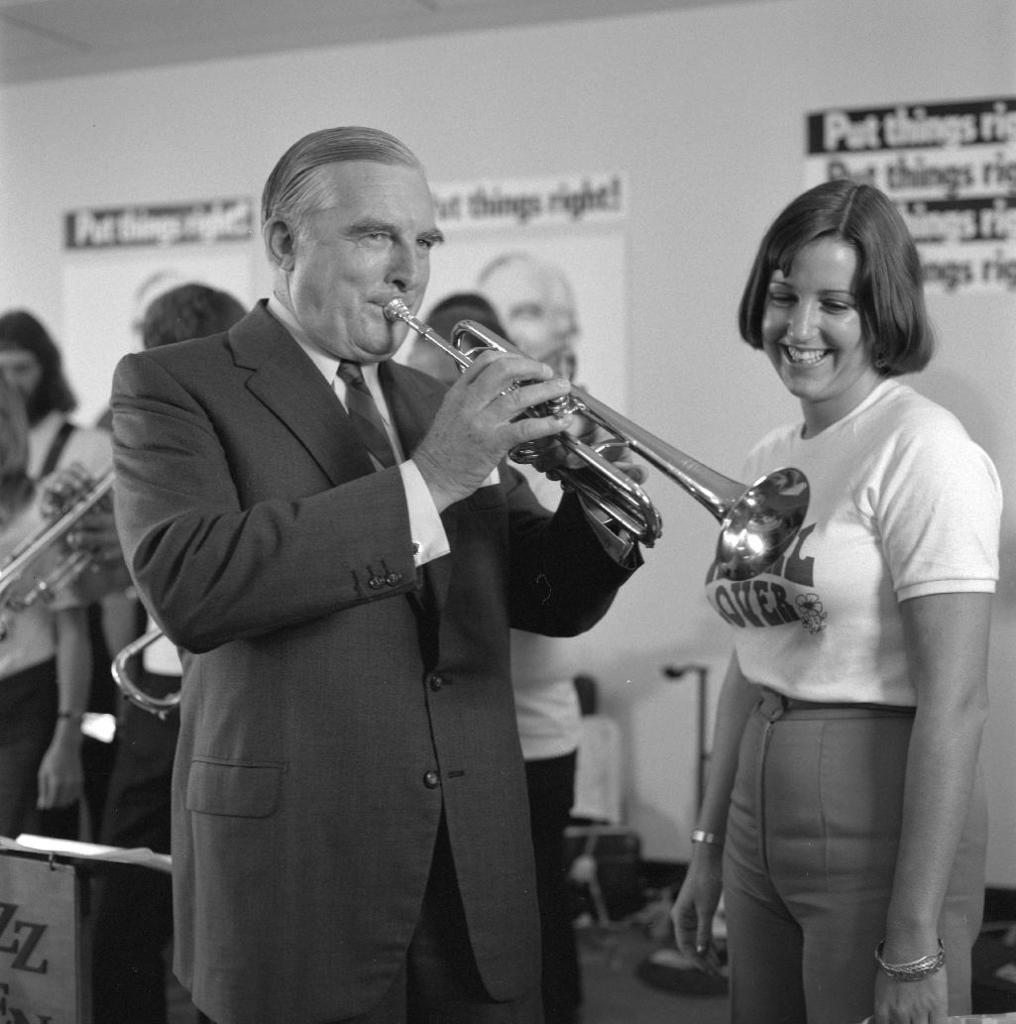In one or two sentences, can you explain what this image depicts? This image is a black and white image image. This image is taken indoors. In the background there is a wall with a few posts on it. There are a few images and there is a text on the posters. At the top of the image there is a ceiling. On the left side of the image a few people are standing on the floor and there is a board with a text on it and a man is holding a musical instrument in his hands. In the middle of the image a man is standing and playing music with a musical instrument and there is another man. On the right side of the image a woman is standing on the floor and she is with a smiling face. There are a few objects on the floor. 